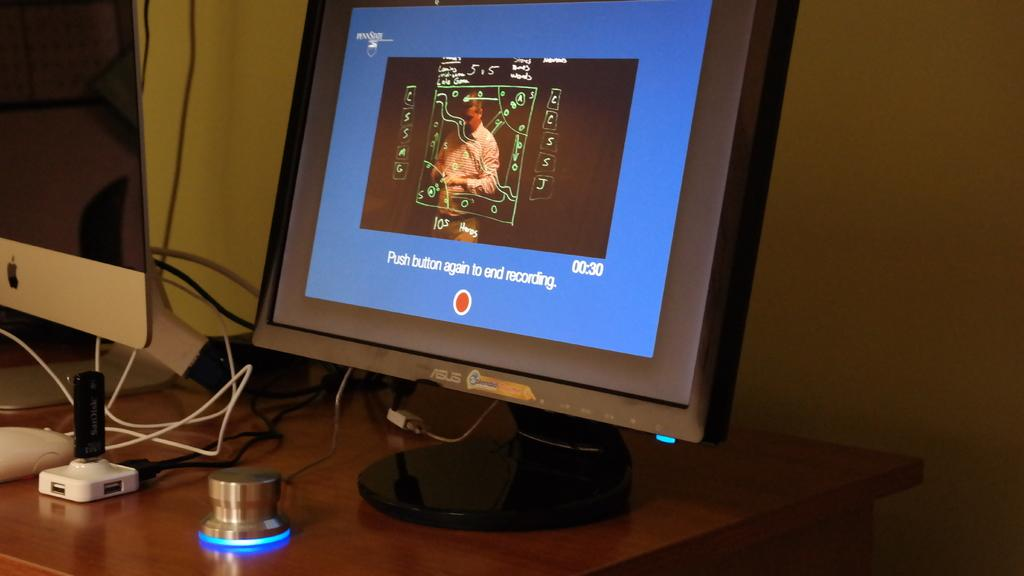<image>
Describe the image concisely. An Asus monitor displays a recording in progress with instructions on how to end it. 